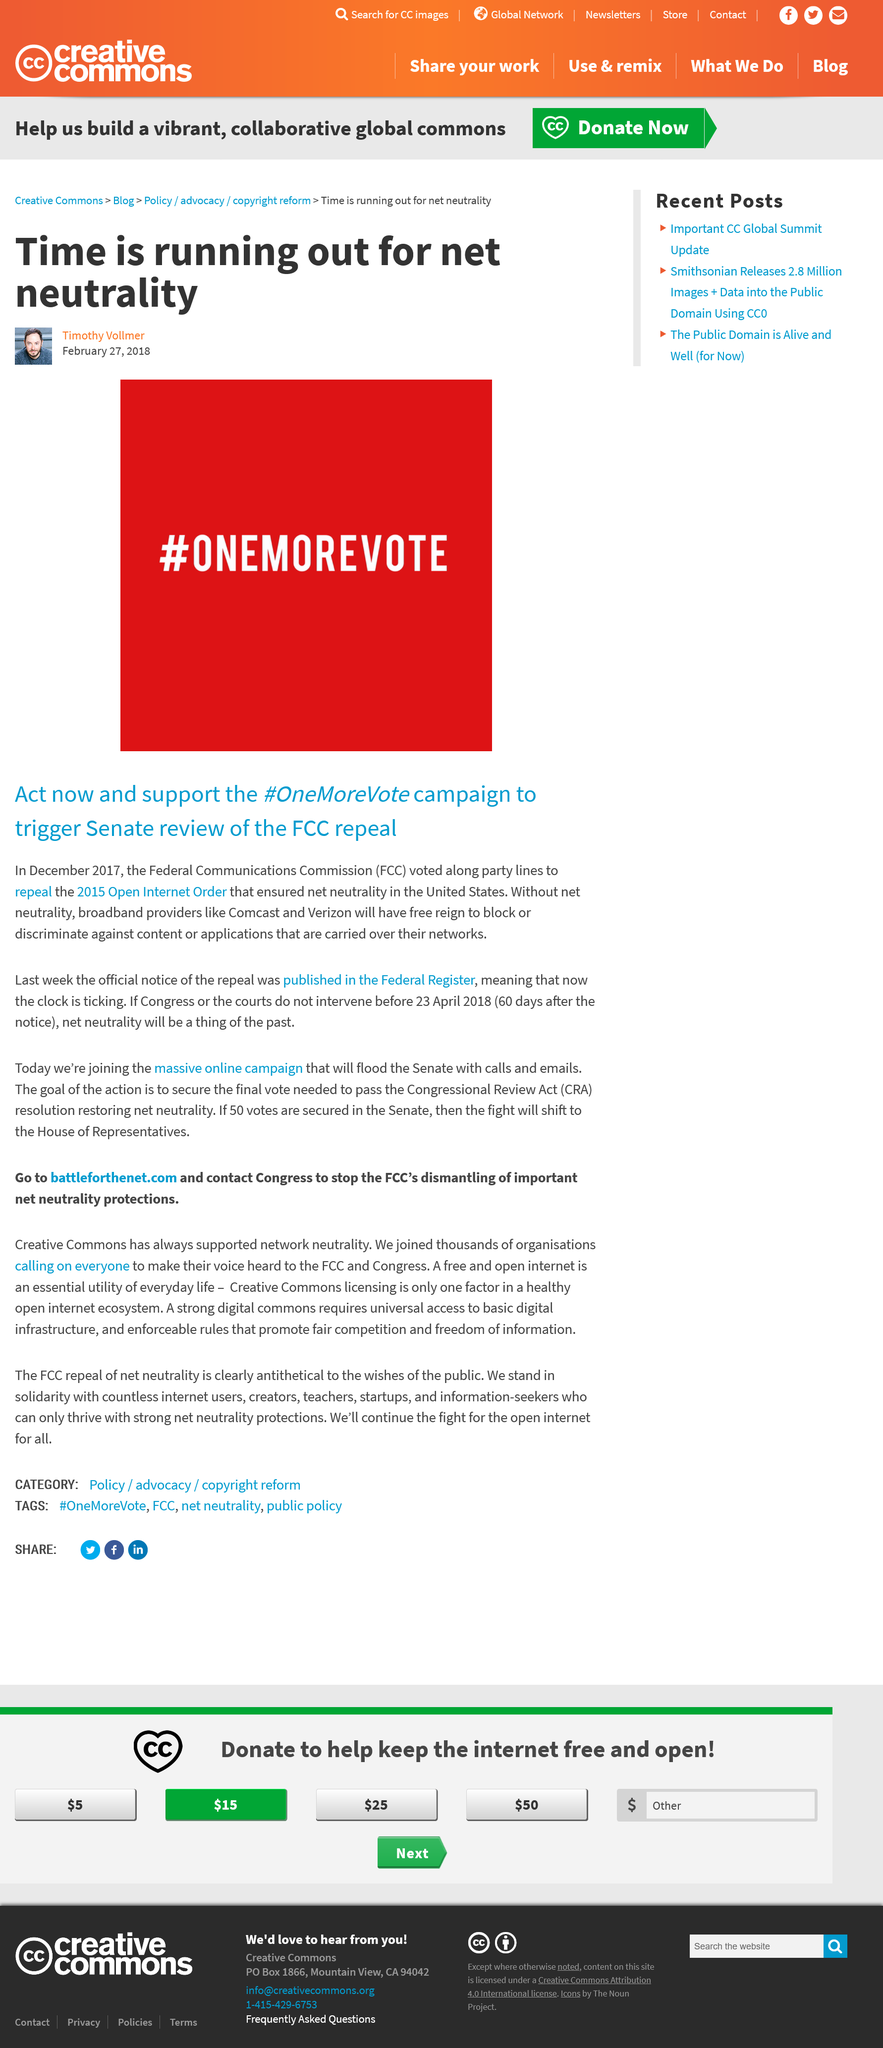Specify some key components in this picture. On December 14, 2017, the Federal Communications Commission (FCC) voted to repeal the 2015 Open Internet Order along party lines. The Federal Communications Commission (FCC) is dismantling crucial net neutrality protections. Net neutrality ensures that broadband providers do not discriminate against or block content carried over their networks. If net neutrality is repealed, broadband providers may have the power to block or discriminate against content, potentially stifling free expression and innovation. What has CC always supported? Net neutrality. It has always supported net neutrality. The hashtag in the image is used to support the campaign for the Senate to review and overturn the FCC's decision to repeal net neutrality. 